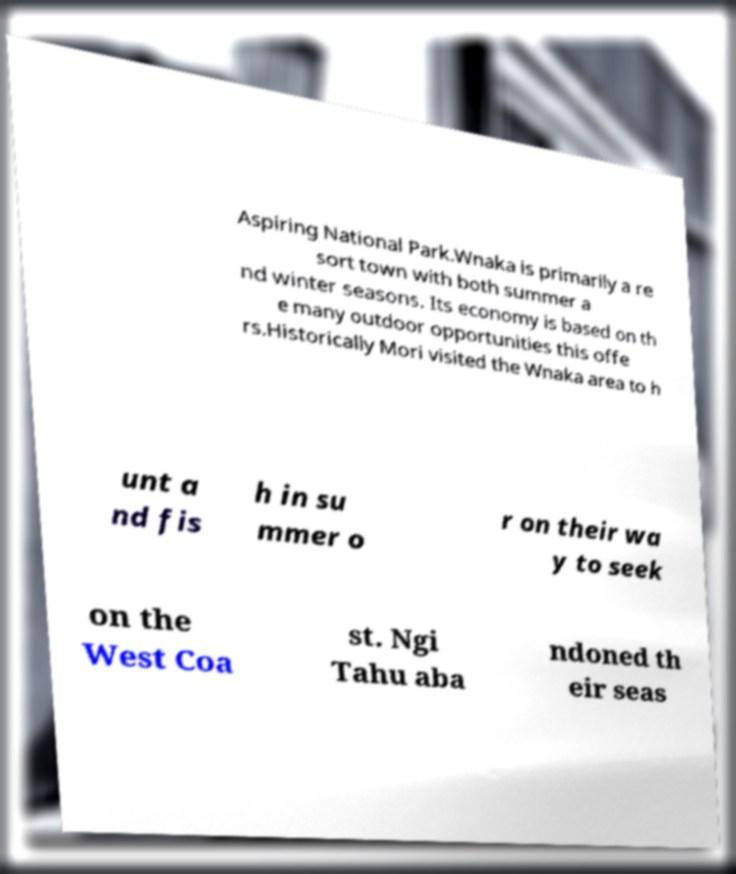Could you extract and type out the text from this image? Aspiring National Park.Wnaka is primarily a re sort town with both summer a nd winter seasons. Its economy is based on th e many outdoor opportunities this offe rs.Historically Mori visited the Wnaka area to h unt a nd fis h in su mmer o r on their wa y to seek on the West Coa st. Ngi Tahu aba ndoned th eir seas 